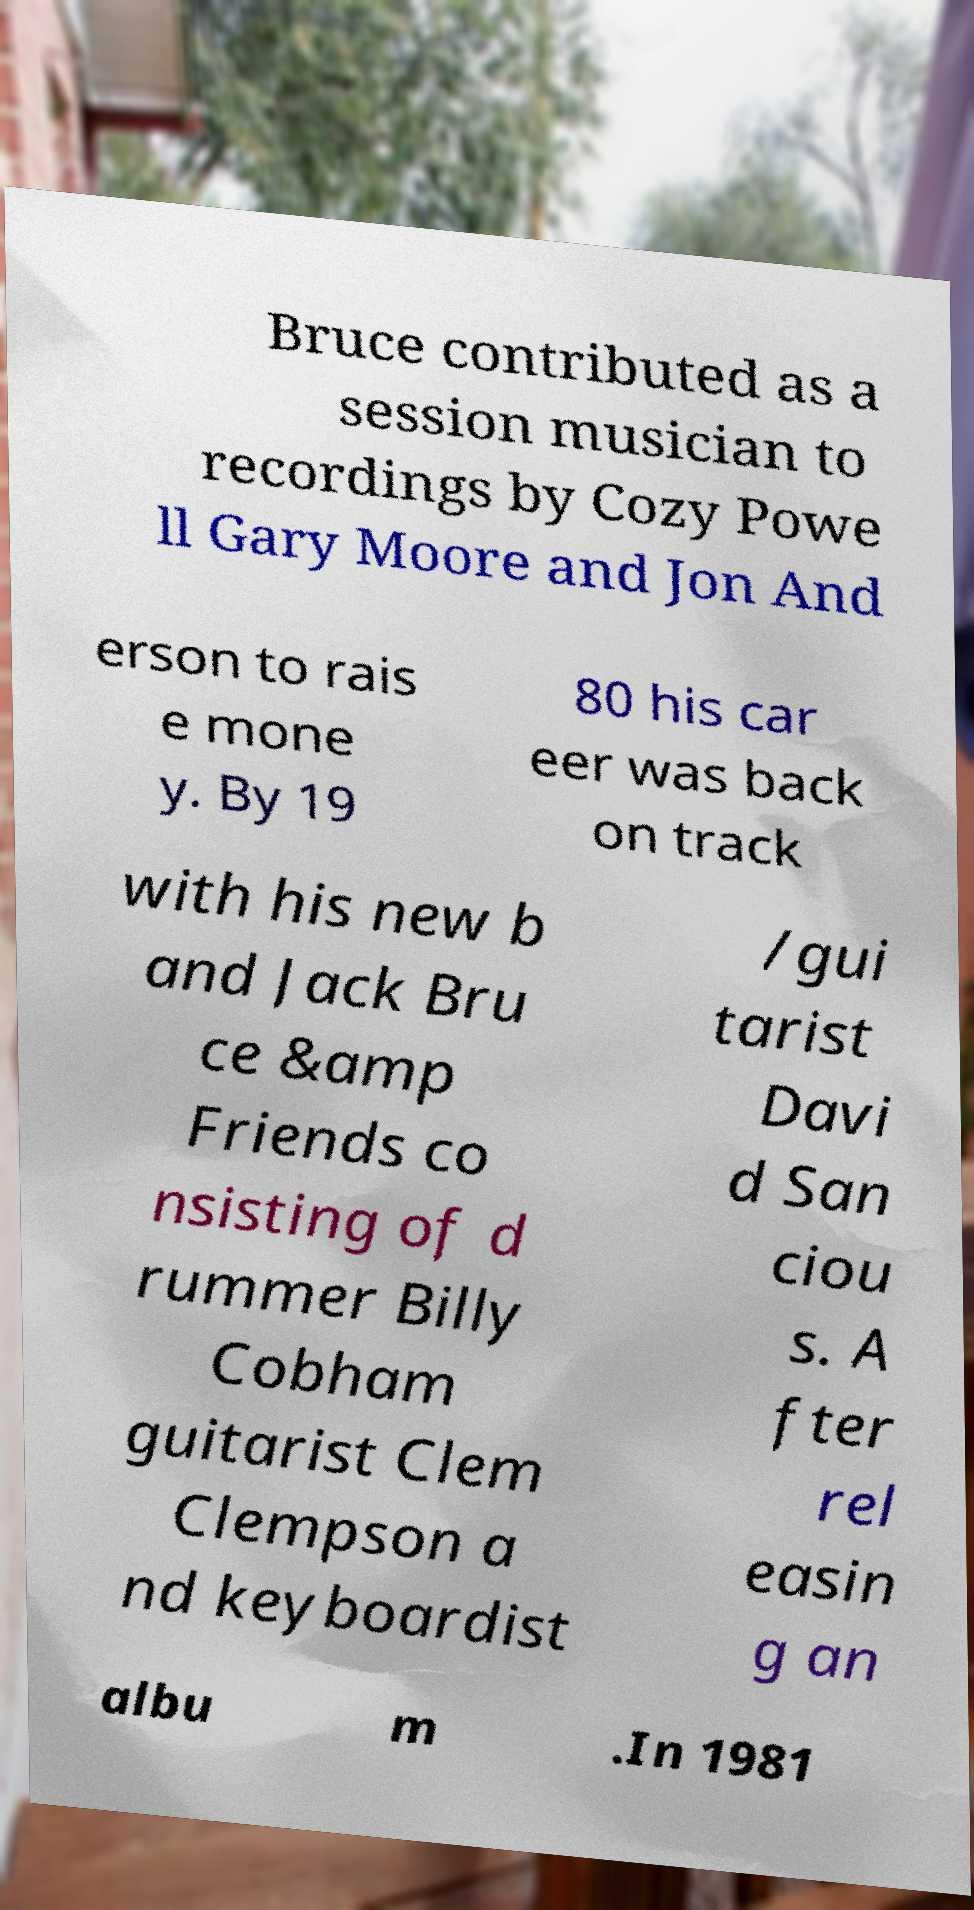Can you accurately transcribe the text from the provided image for me? Bruce contributed as a session musician to recordings by Cozy Powe ll Gary Moore and Jon And erson to rais e mone y. By 19 80 his car eer was back on track with his new b and Jack Bru ce &amp Friends co nsisting of d rummer Billy Cobham guitarist Clem Clempson a nd keyboardist /gui tarist Davi d San ciou s. A fter rel easin g an albu m .In 1981 